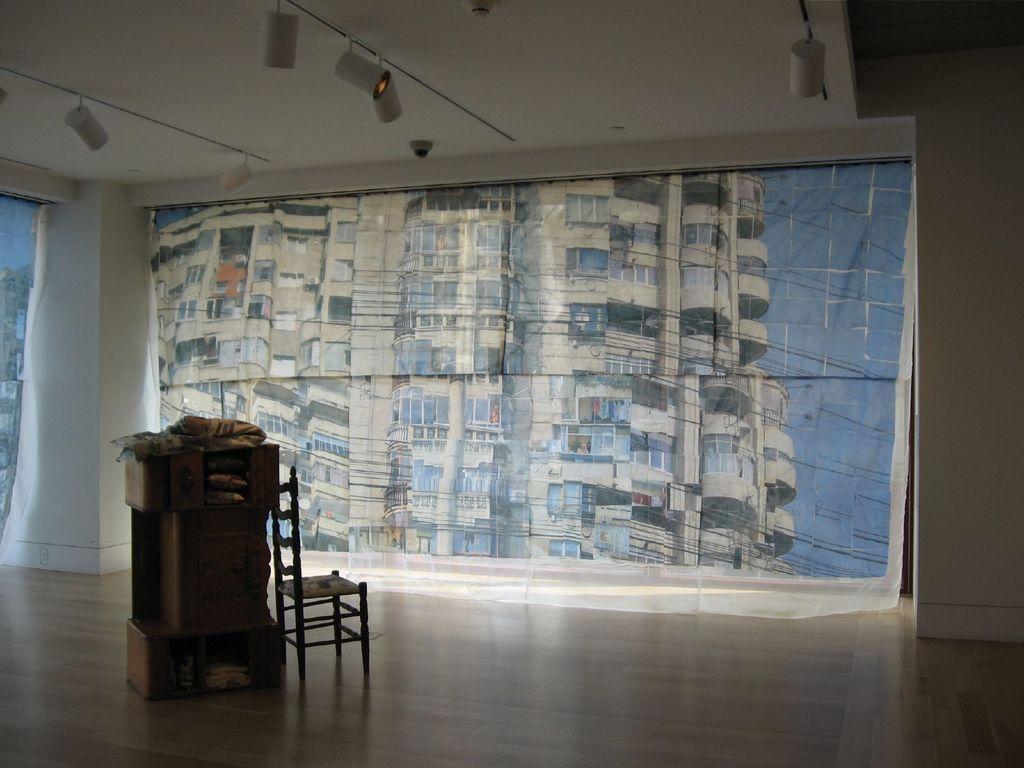Please provide a concise description of this image. In this image we can see a chair and some object are placed on the wooden floor. In the background, we can see the glass windows through which we can see the buildings and here we can see the ceiling lights. 